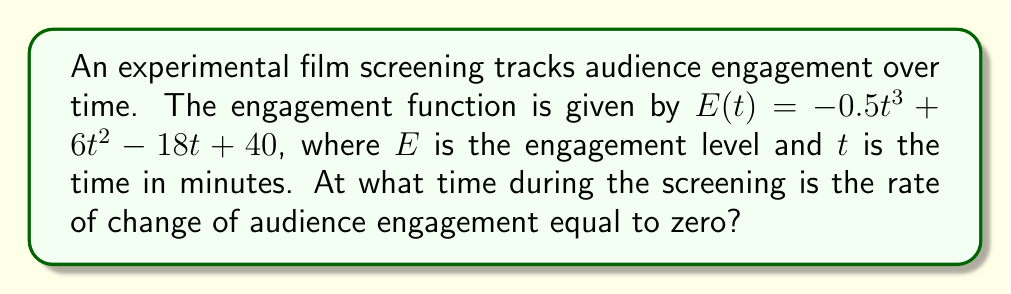Give your solution to this math problem. To find when the rate of change of audience engagement is zero, we need to follow these steps:

1) The rate of change of engagement is given by the first derivative of $E(t)$. Let's call this $E'(t)$.

2) Calculate $E'(t)$:
   $$E'(t) = \frac{d}{dt}(-0.5t^3 + 6t^2 - 18t + 40)$$
   $$E'(t) = -1.5t^2 + 12t - 18$$

3) We want to find when $E'(t) = 0$:
   $$-1.5t^2 + 12t - 18 = 0$$

4) This is a quadratic equation. We can solve it using the quadratic formula:
   $$t = \frac{-b \pm \sqrt{b^2 - 4ac}}{2a}$$
   where $a = -1.5$, $b = 12$, and $c = -18$

5) Substituting these values:
   $$t = \frac{-12 \pm \sqrt{12^2 - 4(-1.5)(-18)}}{2(-1.5)}$$
   $$t = \frac{-12 \pm \sqrt{144 - 108}}{-3}$$
   $$t = \frac{-12 \pm \sqrt{36}}{-3}$$
   $$t = \frac{-12 \pm 6}{-3}$$

6) This gives us two solutions:
   $$t = \frac{-12 + 6}{-3} = 2$$ or $$t = \frac{-12 - 6}{-3} = 6$$

Therefore, the rate of change of audience engagement is zero at 2 minutes and 6 minutes into the screening.
Answer: 2 minutes and 6 minutes 